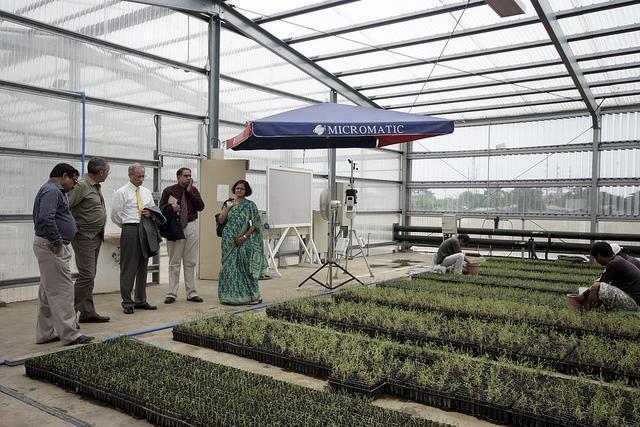What might the temperature be like where they are standing?
Choose the correct response and explain in the format: 'Answer: answer
Rationale: rationale.'
Options: Dry, cold, moist, humid. Answer: humid.
Rationale: Plants need moisture and warmth to grow 